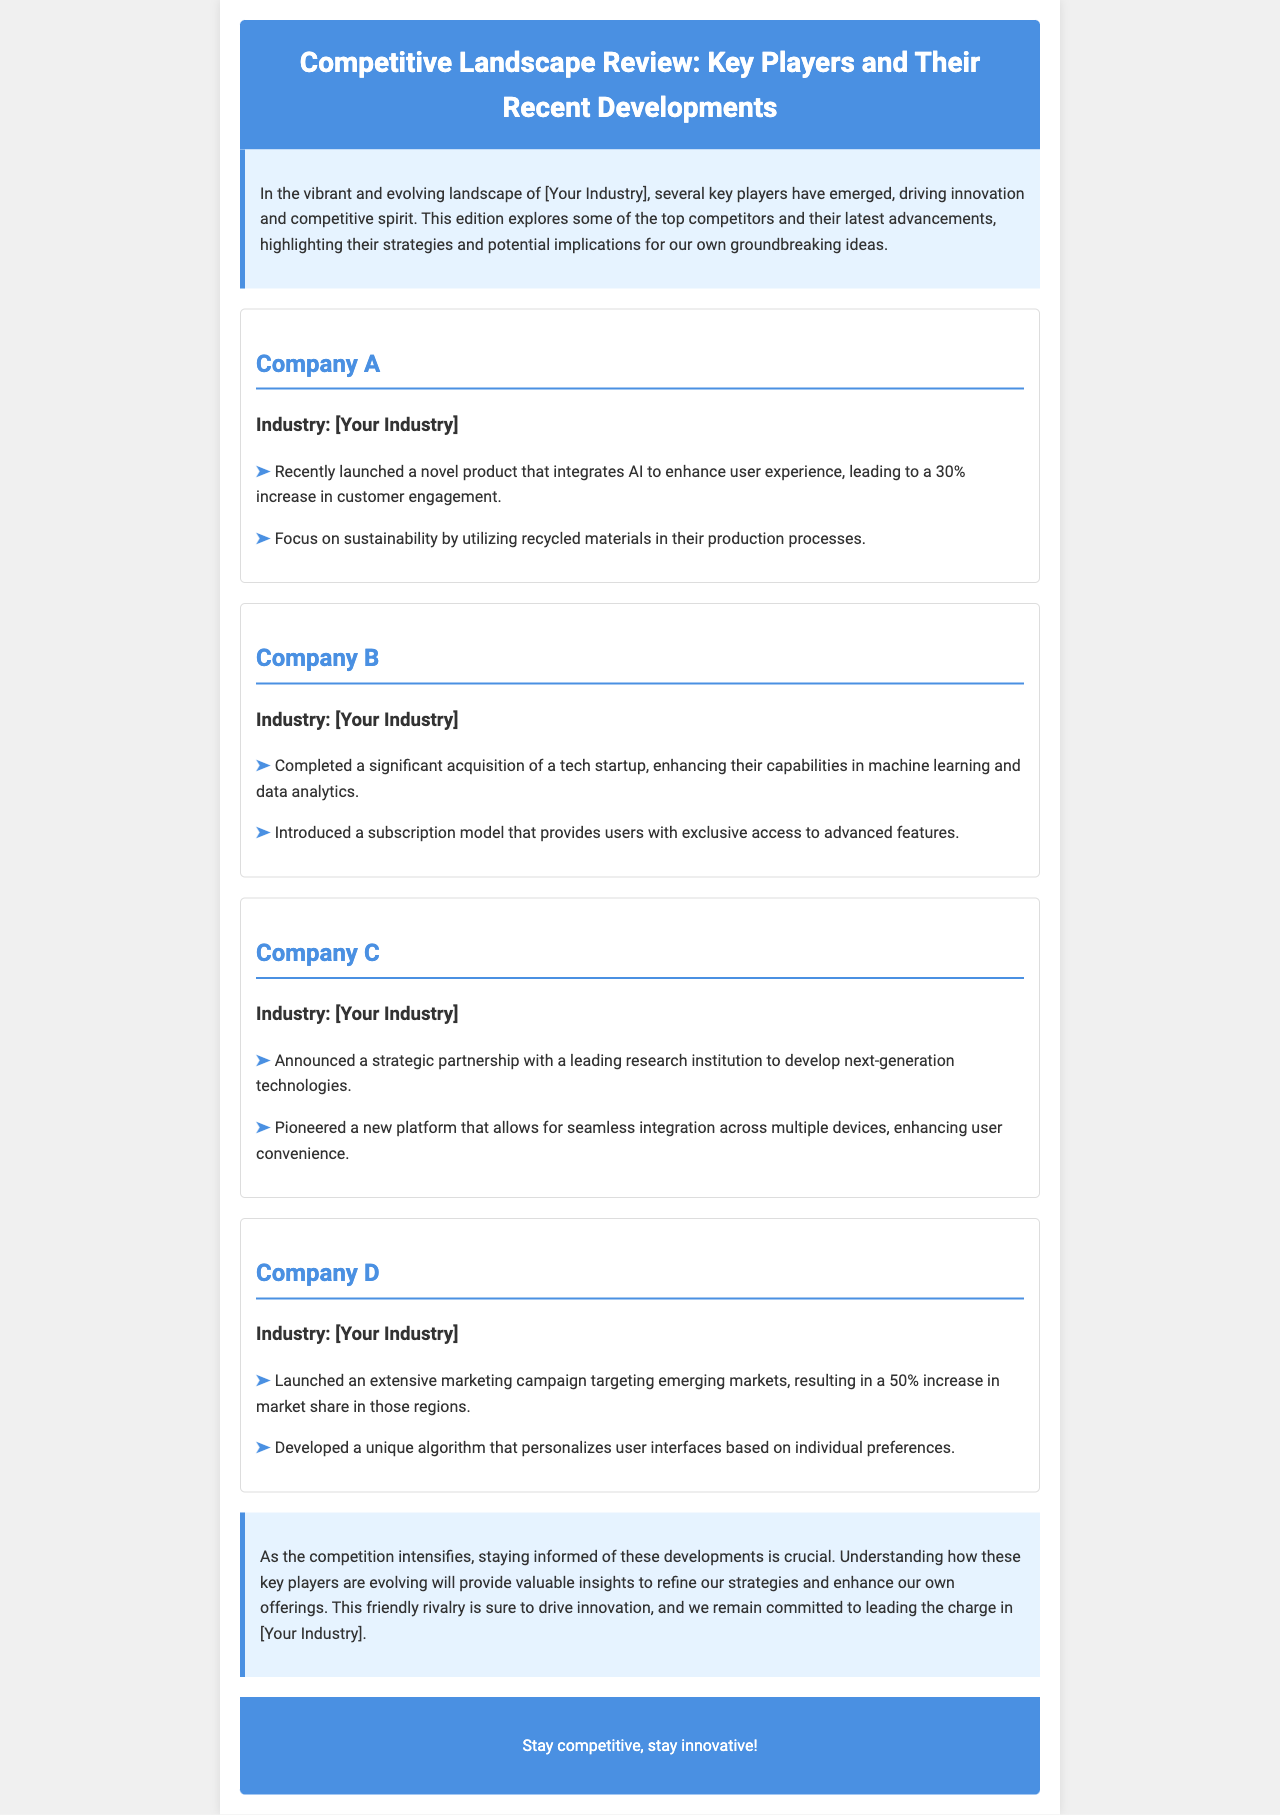What is the industry of Company A? The document specifies the industry of Company A as [Your Industry].
Answer: [Your Industry] What percentage increase in customer engagement did Company A achieve? The document states that Company A's recent product launch led to a 30% increase in customer engagement.
Answer: 30% Which company completed a significant acquisition? The document mentions that Company B completed a significant acquisition of a tech startup.
Answer: Company B What was the increase in market share for Company D in emerging markets? The document notes that Company D's marketing campaign resulted in a 50% increase in market share in those regions.
Answer: 50% What type of model did Company B introduce? According to the document, Company B introduced a subscription model.
Answer: Subscription model What was the focus of Company C's strategic partnership? The document indicates that Company C's strategic partnership aimed to develop next-generation technologies.
Answer: Next-generation technologies What common theme is highlighted in the conclusion of the newsletter? The conclusion emphasizes the importance of staying informed about competitive developments.
Answer: Staying informed What does the newsletter suggest about the rivalry among companies? The document suggests that the friendly rivalry is expected to drive innovation.
Answer: Drive innovation 